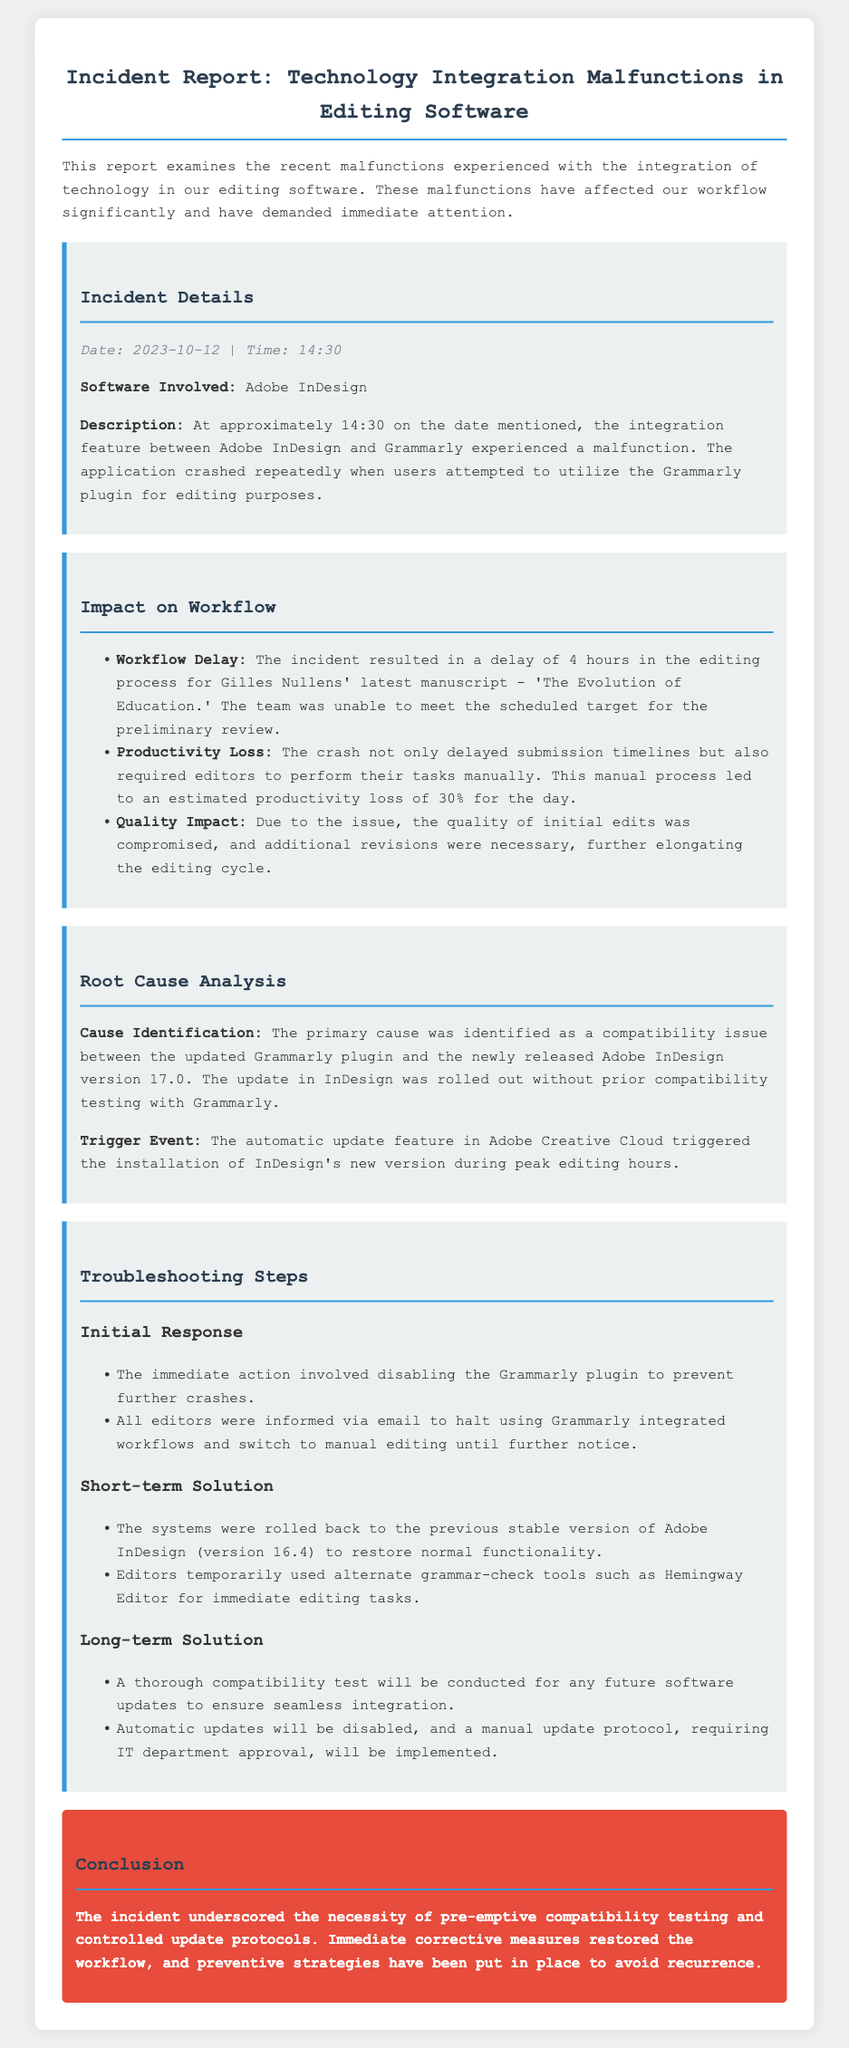What is the date of the incident? The date of the incident is stated in the document as October 12, 2023.
Answer: October 12, 2023 What software was involved in the incident? The software involved is identified in the incident report.
Answer: Adobe InDesign What was the duration of the workflow delay? The document mentions that the workflow delay lasted for a specified number of hours.
Answer: 4 hours What was the estimated productivity loss percentage? The productivity loss is detailed in the report, expressed as a percentage.
Answer: 30% What was the primary cause of the malfunction? The report specifies a compatibility issue as the main cause.
Answer: Compatibility issue What triggered the installation of the new version? The trigger event for the installation is explained in the document.
Answer: Automatic update feature What short-term solution was implemented? The document discusses a specific solution that required action.
Answer: Roll back to version 16.4 What tool did editors use temporarily for editing tasks? The report mentions an alternate tool used during the malfunction.
Answer: Hemingway Editor What is the conclusion regarding the incident? The conclusion emphasizes the importance of a specific protocol for future updates.
Answer: Compatibility testing and controlled update protocols 